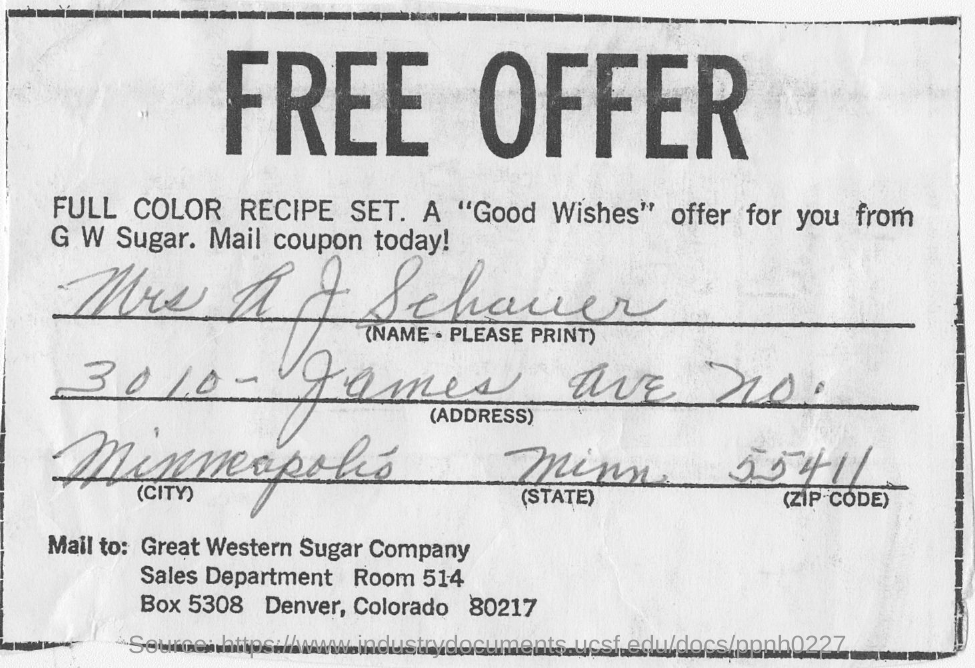What is the title of the document?
Give a very brief answer. Free Offer. 